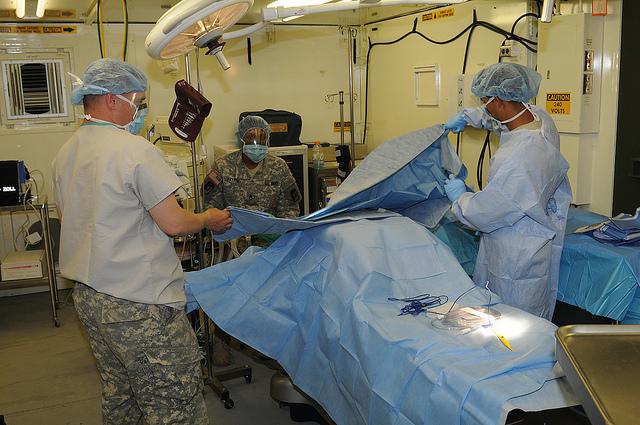Is the environment sterile?
Quick response, please. Yes. What is the blue object on the man's head?
Concise answer only. Hair net. Why do the doctors wear camo?
Answer briefly. Army doctors. Is this a firefighter?
Short answer required. No. 